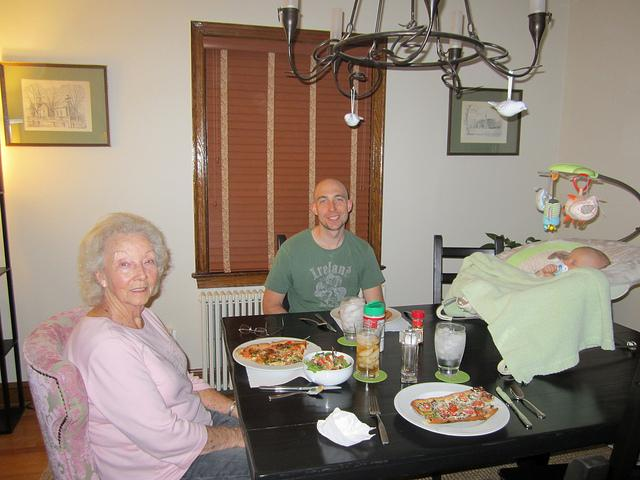What meal are the people most likely eating at the table? dinner 